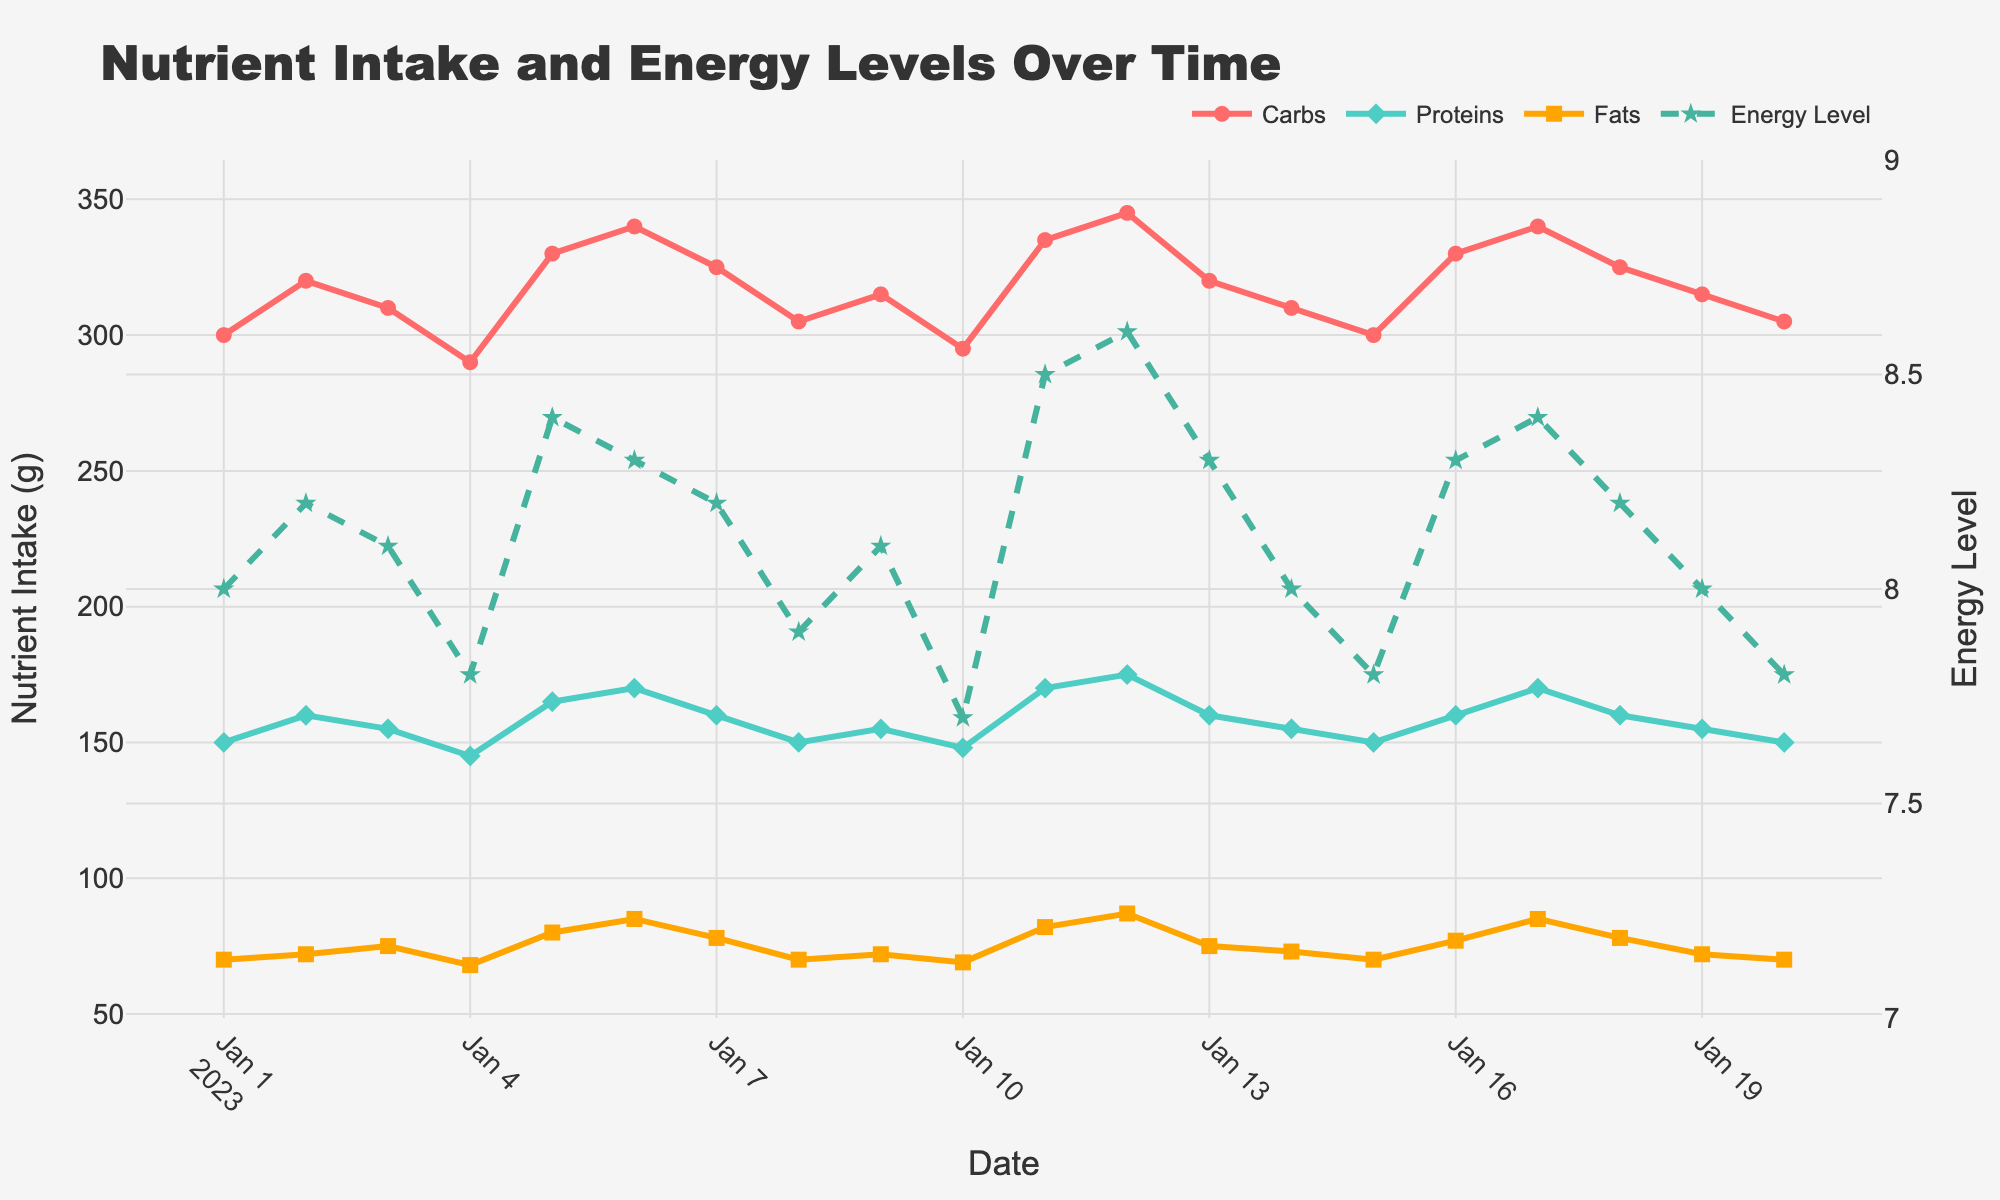What is the title of the figure? The title of the figure is usually displayed prominently at the top. By looking at the top of the figure, we can see the text "Nutrient Intake and Energy Levels Over Time".
Answer: Nutrient Intake and Energy Levels Over Time How many different nutrients are tracked in the figure? The figure shows three different colored lines representing carbs, proteins, and fats. By counting these lines, we see that there are three nutrients tracked.
Answer: Three What color represents proteins in the figure? The protein label and line are color-coded. By observing the figure, we notice that the proteins are represented by a greenish-blue color.
Answer: Greenish-blue Can you notice any specific trend in the energy level over the given dates? The energy level is shown as a dashed line. By following the dashed line over time, we see that it fluctuates between approximately 7.7 and 8.6. It appears to have moderate variability but generally stays within a narrow range.
Answer: Moderate variability On which date does the energy level peak? To find the peak energy level, follow the dashed line to its highest point. The highest energy level is 8.6, which occurs on 2023-01-12.
Answer: 2023-01-12 Which nutrient shows the highest single value intake and on what date? Examining the peaks of the three nutrient lines, the highest single value intake is for fats, peaked at 87 grams on 2023-01-12.
Answer: Fats on 2023-01-12 Are there any dates where both carbs and proteins reach their minimum intake? By closely observing the minima of the carbs and proteins lines, we notice that these don’t coincide on the same date. Carbs reach their minimum on 2023-01-04 while proteins reach their minimum on 2023-01-10 and 2023-01-20.
Answer: No On what dates do carbs and fats show a notably high intake together? By identifying simultaneous peaks or high values in the carbs and fats lines, we see that both show high intakes on 2023-01-12 (carbs at 345g and fats at 87g).
Answer: 2023-01-12 How does the intake of proteins correlate with energy levels over time? To understand the correlation, visually compare the proteins line with the energy level line. When protein intake increases, energy levels tend to increase as well, implying a positive correlation. For instance, high protein values on dates like 2023-01-12 correspond to high energy levels.
Answer: Positive correlation Between 2023-01-15 and 2023-01-20, does the carbs intake increase or decrease? By observing the carbs line between these dates, we note that it starts at 300 grams on 2023-01-15 and decreases to 305 grams on 2023-01-20.
Answer: Increases 